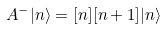<formula> <loc_0><loc_0><loc_500><loc_500>A ^ { - } | n \rangle = [ n ] [ n + 1 ] | n \rangle</formula> 